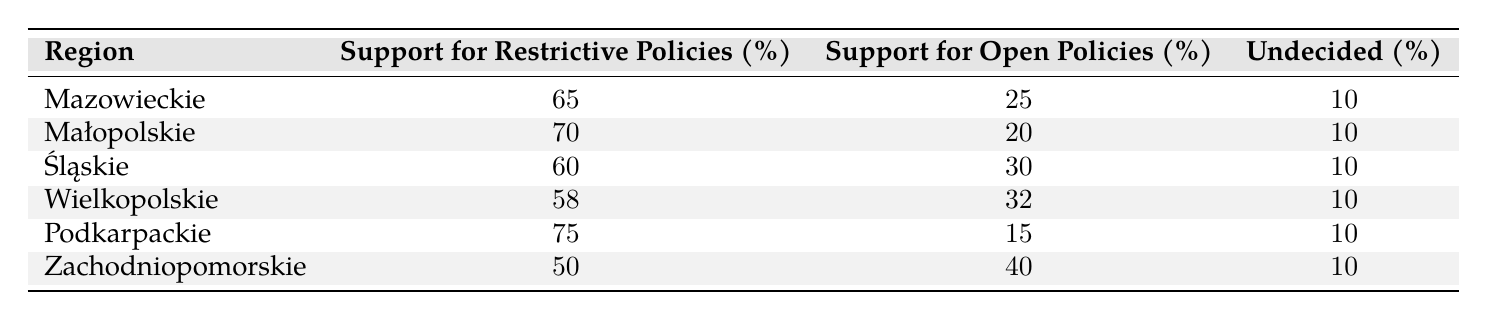What region has the highest support for restrictive immigration policies? By reviewing the "Support for Restrictive Policies" column, I see that Podkarpackie has the highest percentage at 75%.
Answer: Podkarpackie Which region shows the least support for restrictive immigration policies? Looking at the same column, Zachodniopomorskie has the least support with 50%.
Answer: Zachodniopomorskie What is the average support for open immigration policies across all regions? To find the average, I sum the percentages: (25 + 20 + 30 + 32 + 15 + 40) = 172. There are 6 regions, so the average is 172 / 6 = 28.67.
Answer: 28.67 Is there a region where support for open immigration policies is higher than 35%? By scanning the "Support for Open Policies" column, I see that only Zachodniopomorskie has a percentage of 40%, which is higher than 35%.
Answer: Yes Which regions have undecided percentages equal to 10%? Every region listed has an undecided percentage of 10%. Thus, all regions qualify.
Answer: All regions What is the difference in support for restrictive policies between Mazowieckie and Małopolskie? I check the values in the "Support for Restrictive Policies" column: Mazowieckie has 65%, and Małopolskie has 70%. The difference is 70 - 65 = 5%.
Answer: 5% Are there more regions in Poland that support restrictive immigration policies above 60% or below 60%? The regions with support above 60% are Mazowieckie, Małopolskie, and Podkarpackie (total 3), while regions with less than 60% are Śląskie, Wielkopolskie, and Zachodniopomorskie (total 3). Therefore, they are equal.
Answer: Equal What percentage of the people in Podkarpackie support open immigration policies? Directly from the table, Podkarpackie has a support percentage for open immigration policies of 15%.
Answer: 15% Does the support for restrictive policies drop below 60% in any region? Upon examining the "Support for Restrictive Policies" column, I see that Zachodniopomorskie has a support percentage of 50%, which is below 60%.
Answer: Yes 